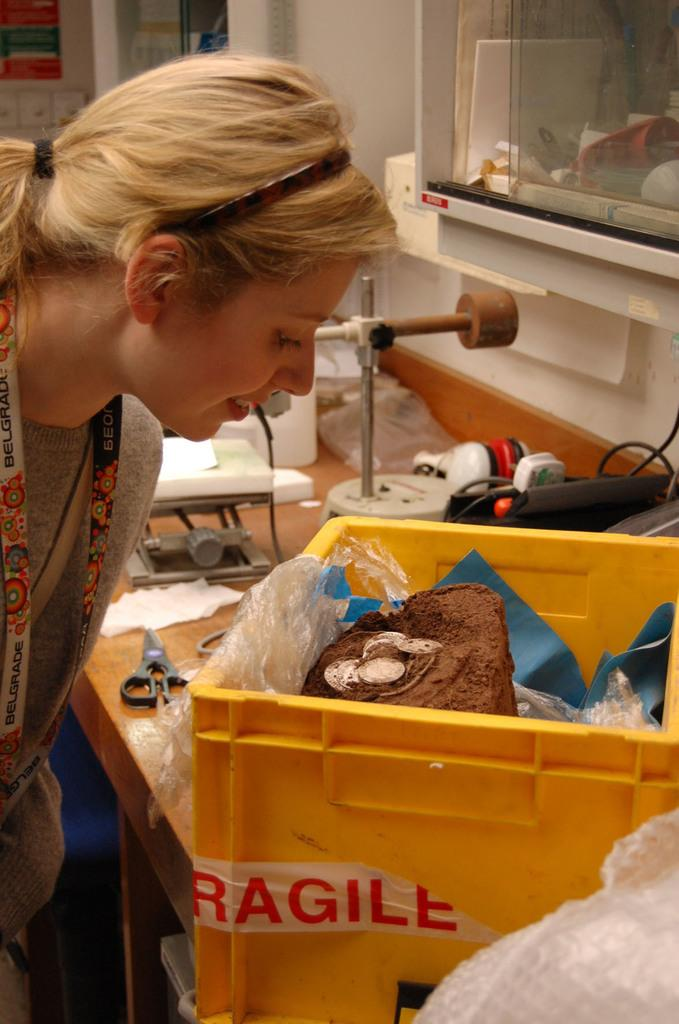<image>
Describe the image concisely. A woman peers into a yellow container of fragile objects. 